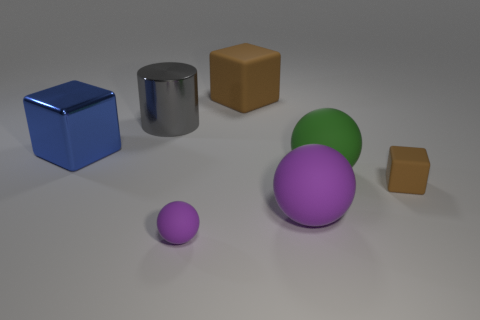There is a large cube in front of the large shiny object that is behind the big shiny object left of the large gray thing; what is it made of?
Provide a succinct answer. Metal. Are there more big balls behind the tiny brown block than big metallic cylinders that are behind the large shiny cylinder?
Your answer should be very brief. Yes. How many matte objects are either large cylinders or purple blocks?
Your answer should be compact. 0. There is a large object that is the same color as the tiny block; what shape is it?
Provide a short and direct response. Cube. There is a purple sphere on the left side of the large purple rubber thing; what material is it?
Make the answer very short. Rubber. What number of objects are either big metallic cylinders or big rubber balls that are to the left of the green matte thing?
Ensure brevity in your answer.  2. What is the shape of the purple rubber object that is the same size as the green sphere?
Keep it short and to the point. Sphere. What number of large rubber cubes are the same color as the tiny ball?
Ensure brevity in your answer.  0. Is the brown block in front of the large green sphere made of the same material as the large purple object?
Your answer should be very brief. Yes. The big brown object is what shape?
Your response must be concise. Cube. 